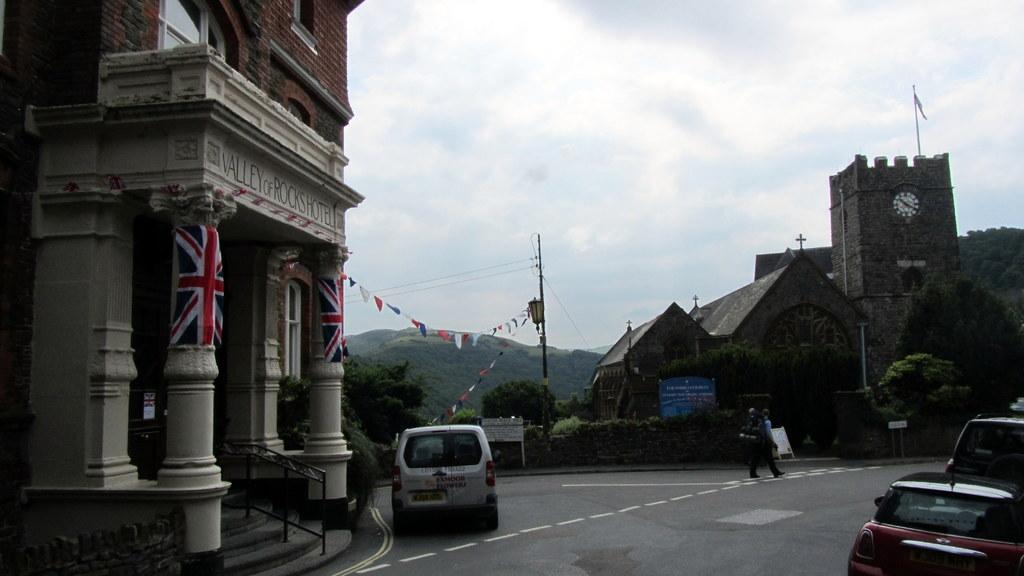<image>
Share a concise interpretation of the image provided. The street scene was taken outside the Valley of Rocks Hotel. 